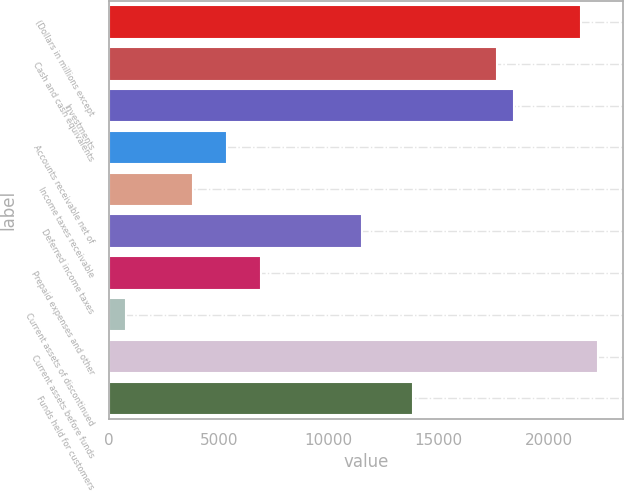Convert chart. <chart><loc_0><loc_0><loc_500><loc_500><bar_chart><fcel>(Dollars in millions except<fcel>Cash and cash equivalents<fcel>Investments<fcel>Accounts receivable net of<fcel>Income taxes receivable<fcel>Deferred income taxes<fcel>Prepaid expenses and other<fcel>Current assets of discontinued<fcel>Current assets before funds<fcel>Funds held for customers<nl><fcel>21484.6<fcel>17648.6<fcel>18415.8<fcel>5373.4<fcel>3839<fcel>11511<fcel>6907.8<fcel>770.2<fcel>22251.8<fcel>13812.6<nl></chart> 